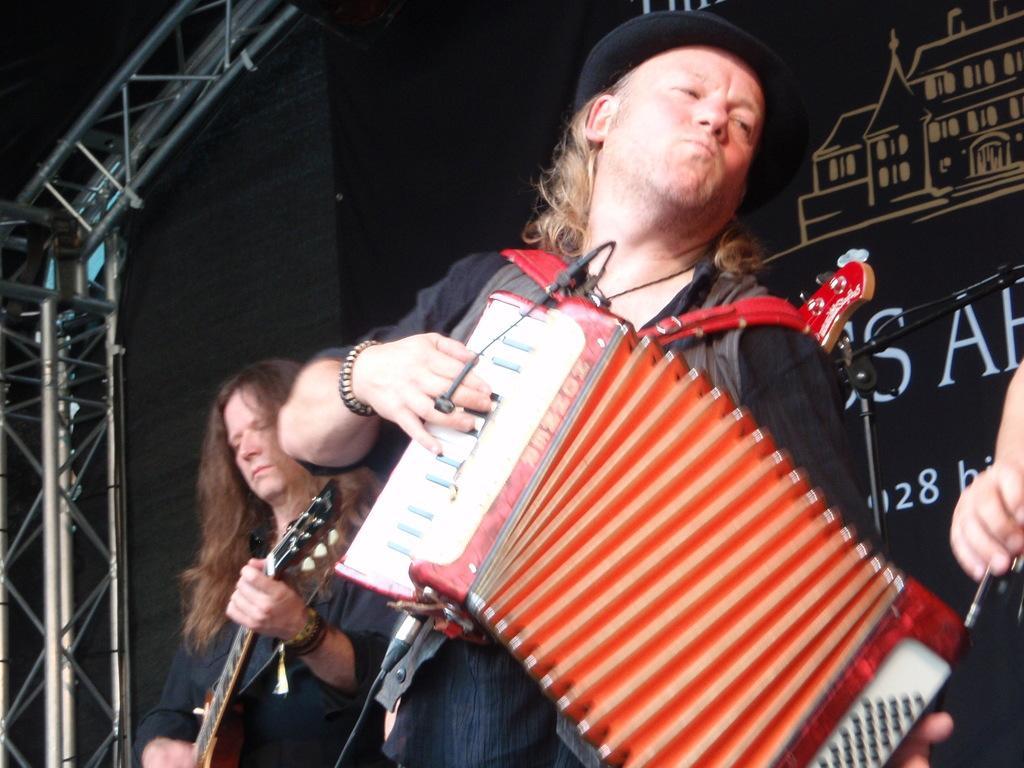In one or two sentences, can you explain what this image depicts? In this image I can see three persons are playing musical instruments. In the background I can see a wall and metal rods. This image is taken may be on the stage. 